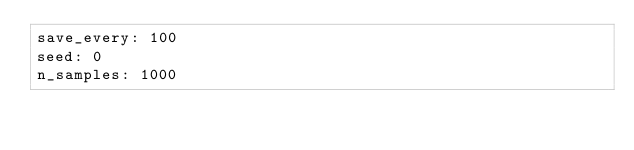Convert code to text. <code><loc_0><loc_0><loc_500><loc_500><_YAML_>save_every: 100
seed: 0
n_samples: 1000</code> 